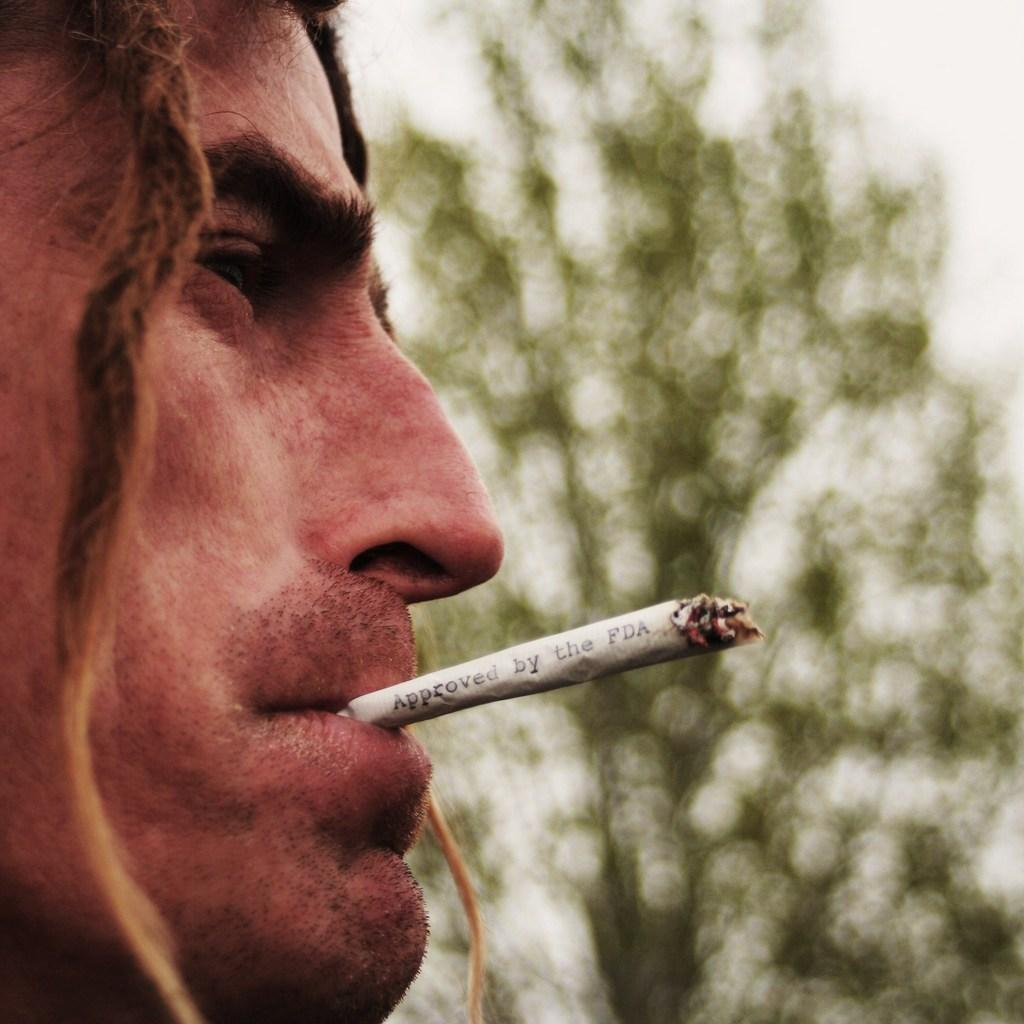What is in the foreground of the image? There is a person in the foreground of the image. What is the person holding in their mouth? The person is holding a cigarette in their mouth. What can be seen in the background of the image? There is sky and a tree visible in the background of the image. What type of distribution system is being used for the smoke in the image? There is no smoke present in the image, as the person is holding a cigarette but not smoking it. 